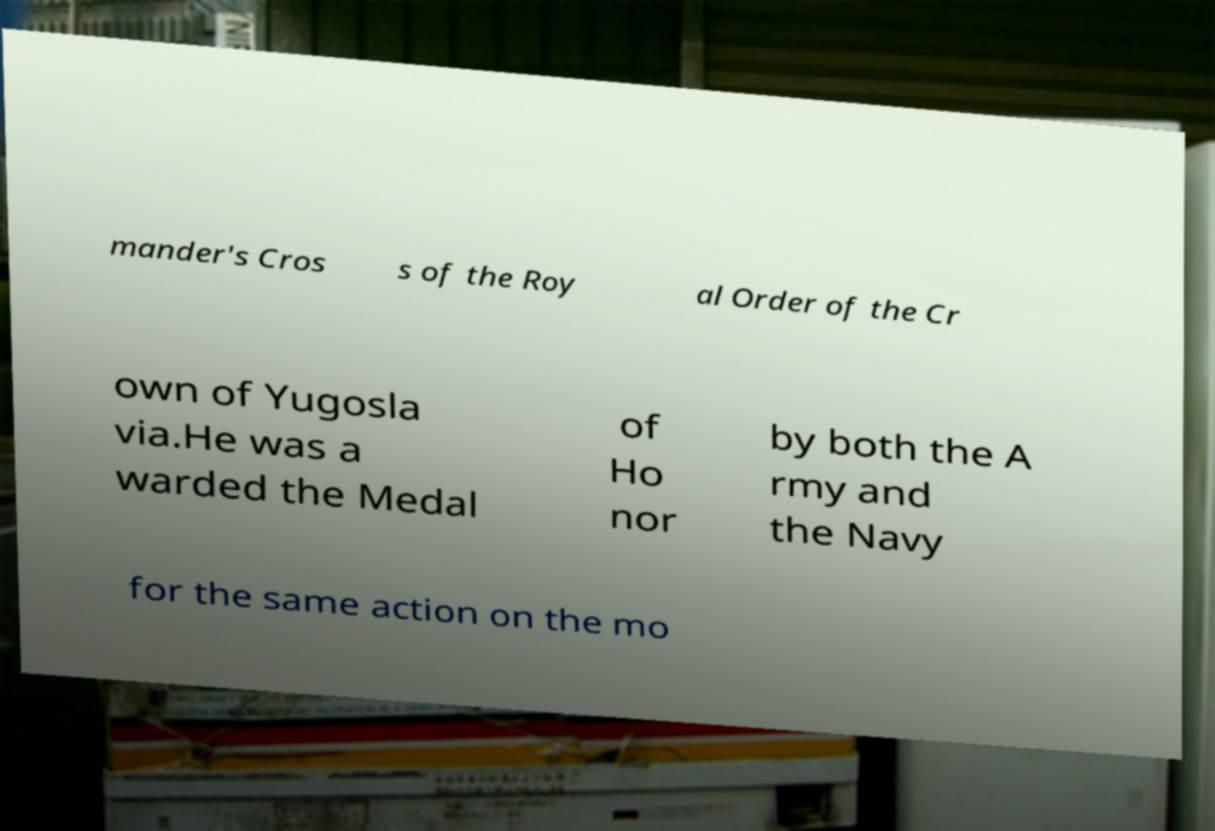Could you assist in decoding the text presented in this image and type it out clearly? mander's Cros s of the Roy al Order of the Cr own of Yugosla via.He was a warded the Medal of Ho nor by both the A rmy and the Navy for the same action on the mo 